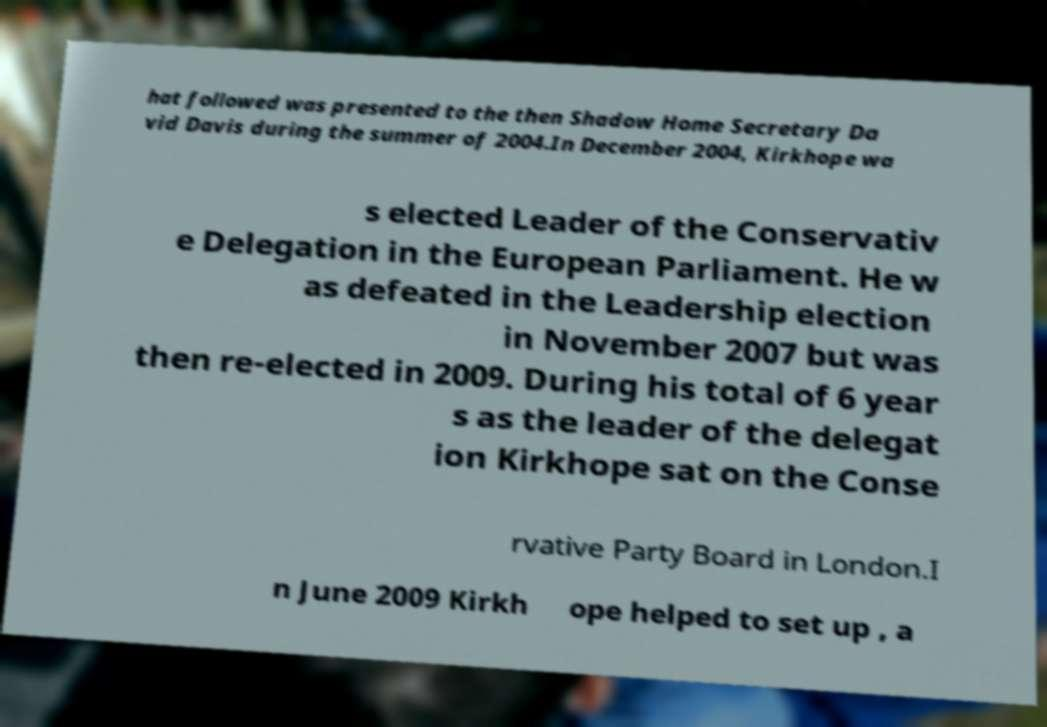For documentation purposes, I need the text within this image transcribed. Could you provide that? hat followed was presented to the then Shadow Home Secretary Da vid Davis during the summer of 2004.In December 2004, Kirkhope wa s elected Leader of the Conservativ e Delegation in the European Parliament. He w as defeated in the Leadership election in November 2007 but was then re-elected in 2009. During his total of 6 year s as the leader of the delegat ion Kirkhope sat on the Conse rvative Party Board in London.I n June 2009 Kirkh ope helped to set up , a 